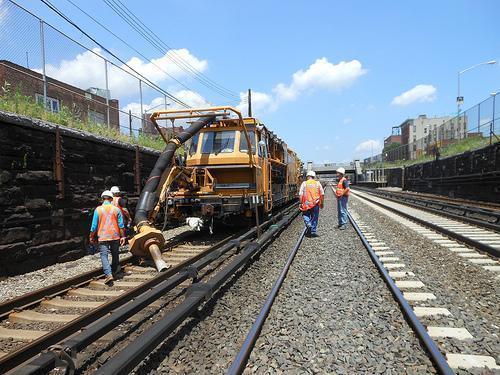How many people are in the picture?
Give a very brief answer. 3. 